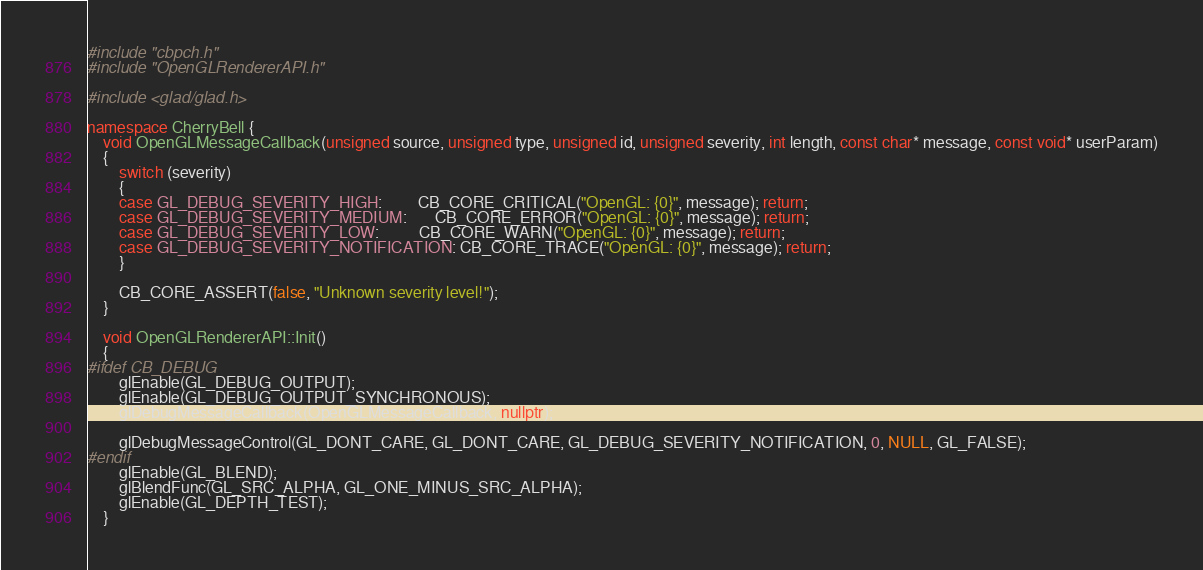Convert code to text. <code><loc_0><loc_0><loc_500><loc_500><_C++_>#include "cbpch.h"
#include "OpenGLRendererAPI.h"

#include <glad/glad.h>

namespace CherryBell {
	void OpenGLMessageCallback(unsigned source, unsigned type, unsigned id, unsigned severity, int length, const char* message, const void* userParam)
	{
		switch (severity)
		{
		case GL_DEBUG_SEVERITY_HIGH:         CB_CORE_CRITICAL("OpenGL: {0}", message); return;
		case GL_DEBUG_SEVERITY_MEDIUM:       CB_CORE_ERROR("OpenGL: {0}", message); return;
		case GL_DEBUG_SEVERITY_LOW:          CB_CORE_WARN("OpenGL: {0}", message); return;
		case GL_DEBUG_SEVERITY_NOTIFICATION: CB_CORE_TRACE("OpenGL: {0}", message); return;
		}

		CB_CORE_ASSERT(false, "Unknown severity level!");
	}

	void OpenGLRendererAPI::Init()
	{
#ifdef CB_DEBUG
		glEnable(GL_DEBUG_OUTPUT);
		glEnable(GL_DEBUG_OUTPUT_SYNCHRONOUS);
		glDebugMessageCallback(OpenGLMessageCallback, nullptr);

		glDebugMessageControl(GL_DONT_CARE, GL_DONT_CARE, GL_DEBUG_SEVERITY_NOTIFICATION, 0, NULL, GL_FALSE);
#endif
		glEnable(GL_BLEND);
		glBlendFunc(GL_SRC_ALPHA, GL_ONE_MINUS_SRC_ALPHA);
		glEnable(GL_DEPTH_TEST);
	}
</code> 